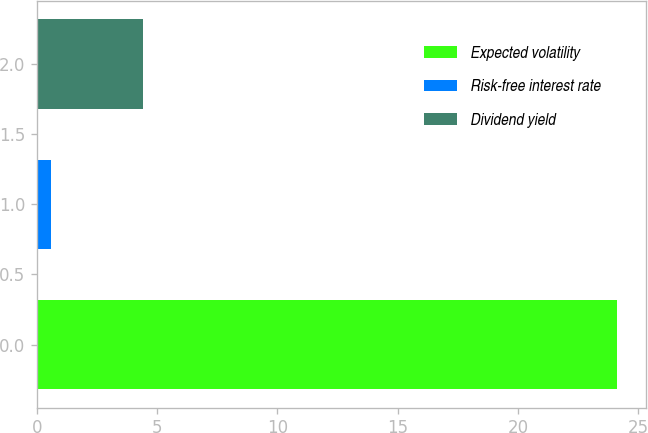Convert chart to OTSL. <chart><loc_0><loc_0><loc_500><loc_500><bar_chart><fcel>Expected volatility<fcel>Risk-free interest rate<fcel>Dividend yield<nl><fcel>24.1<fcel>0.6<fcel>4.4<nl></chart> 